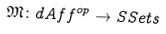Convert formula to latex. <formula><loc_0><loc_0><loc_500><loc_500>\mathfrak { M } \colon d A f f ^ { o p } \to S S e t s</formula> 